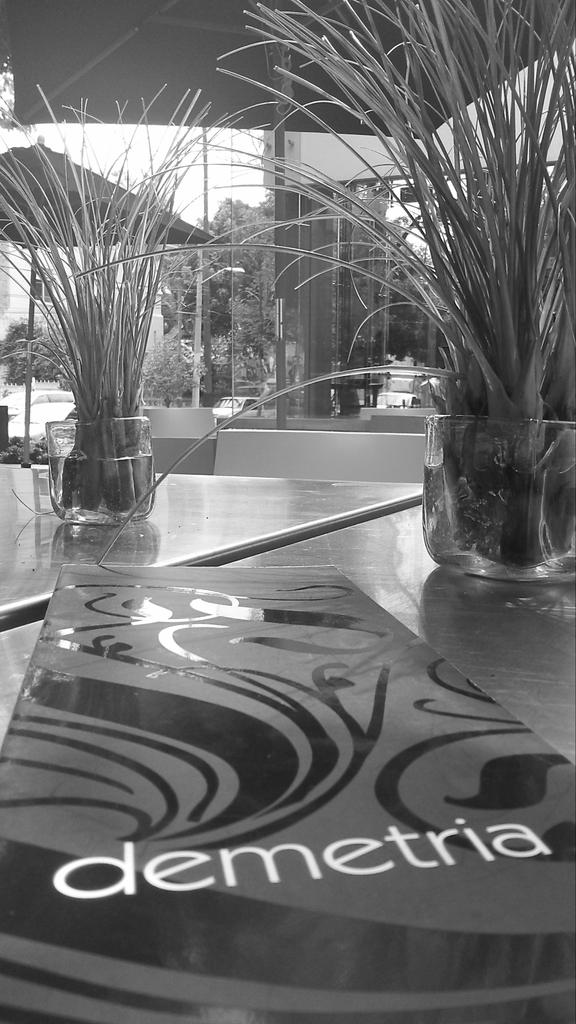How many house plants are visible in the image? There are two house plants in the image. What is placed on the floor in the image? There is a board placed on the floor in the image. What can be seen in the background of the image? There are trees and a wall in the background of the image. What is the color scheme of the image? The image is black and white. What shape is the pencil in the image? There is no pencil present in the image. What achievements has the house plant accomplished in the image? House plants do not have achievements, as they are inanimate objects. 